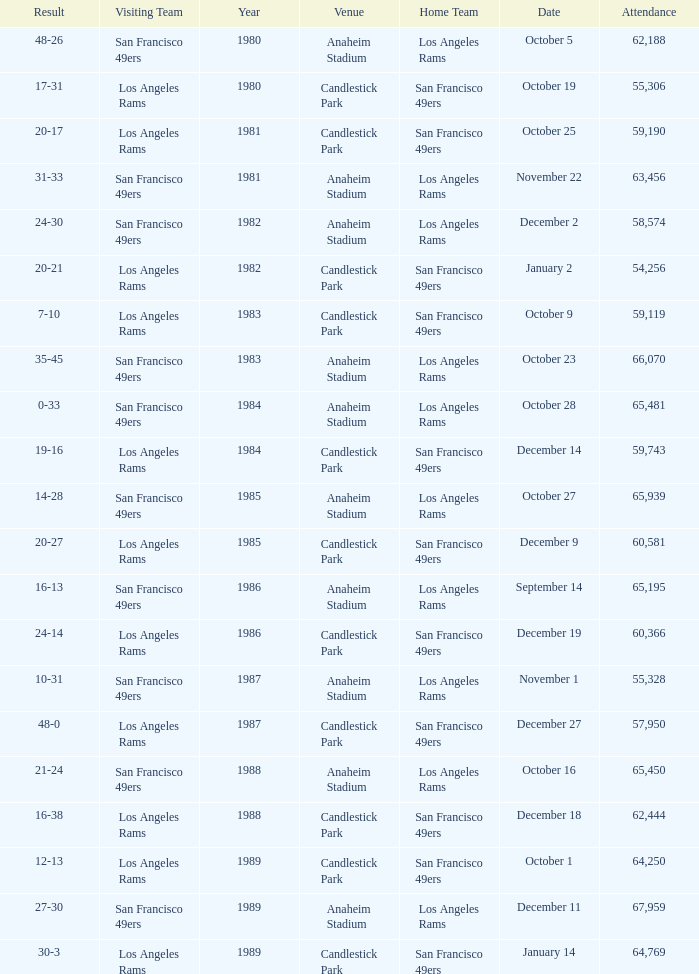What's the total attendance at anaheim stadium after 1983 when the result is 14-28? 1.0. Would you mind parsing the complete table? {'header': ['Result', 'Visiting Team', 'Year', 'Venue', 'Home Team', 'Date', 'Attendance'], 'rows': [['48-26', 'San Francisco 49ers', '1980', 'Anaheim Stadium', 'Los Angeles Rams', 'October 5', '62,188'], ['17-31', 'Los Angeles Rams', '1980', 'Candlestick Park', 'San Francisco 49ers', 'October 19', '55,306'], ['20-17', 'Los Angeles Rams', '1981', 'Candlestick Park', 'San Francisco 49ers', 'October 25', '59,190'], ['31-33', 'San Francisco 49ers', '1981', 'Anaheim Stadium', 'Los Angeles Rams', 'November 22', '63,456'], ['24-30', 'San Francisco 49ers', '1982', 'Anaheim Stadium', 'Los Angeles Rams', 'December 2', '58,574'], ['20-21', 'Los Angeles Rams', '1982', 'Candlestick Park', 'San Francisco 49ers', 'January 2', '54,256'], ['7-10', 'Los Angeles Rams', '1983', 'Candlestick Park', 'San Francisco 49ers', 'October 9', '59,119'], ['35-45', 'San Francisco 49ers', '1983', 'Anaheim Stadium', 'Los Angeles Rams', 'October 23', '66,070'], ['0-33', 'San Francisco 49ers', '1984', 'Anaheim Stadium', 'Los Angeles Rams', 'October 28', '65,481'], ['19-16', 'Los Angeles Rams', '1984', 'Candlestick Park', 'San Francisco 49ers', 'December 14', '59,743'], ['14-28', 'San Francisco 49ers', '1985', 'Anaheim Stadium', 'Los Angeles Rams', 'October 27', '65,939'], ['20-27', 'Los Angeles Rams', '1985', 'Candlestick Park', 'San Francisco 49ers', 'December 9', '60,581'], ['16-13', 'San Francisco 49ers', '1986', 'Anaheim Stadium', 'Los Angeles Rams', 'September 14', '65,195'], ['24-14', 'Los Angeles Rams', '1986', 'Candlestick Park', 'San Francisco 49ers', 'December 19', '60,366'], ['10-31', 'San Francisco 49ers', '1987', 'Anaheim Stadium', 'Los Angeles Rams', 'November 1', '55,328'], ['48-0', 'Los Angeles Rams', '1987', 'Candlestick Park', 'San Francisco 49ers', 'December 27', '57,950'], ['21-24', 'San Francisco 49ers', '1988', 'Anaheim Stadium', 'Los Angeles Rams', 'October 16', '65,450'], ['16-38', 'Los Angeles Rams', '1988', 'Candlestick Park', 'San Francisco 49ers', 'December 18', '62,444'], ['12-13', 'Los Angeles Rams', '1989', 'Candlestick Park', 'San Francisco 49ers', 'October 1', '64,250'], ['27-30', 'San Francisco 49ers', '1989', 'Anaheim Stadium', 'Los Angeles Rams', 'December 11', '67,959'], ['30-3', 'Los Angeles Rams', '1989', 'Candlestick Park', 'San Francisco 49ers', 'January 14', '64,769']]} 